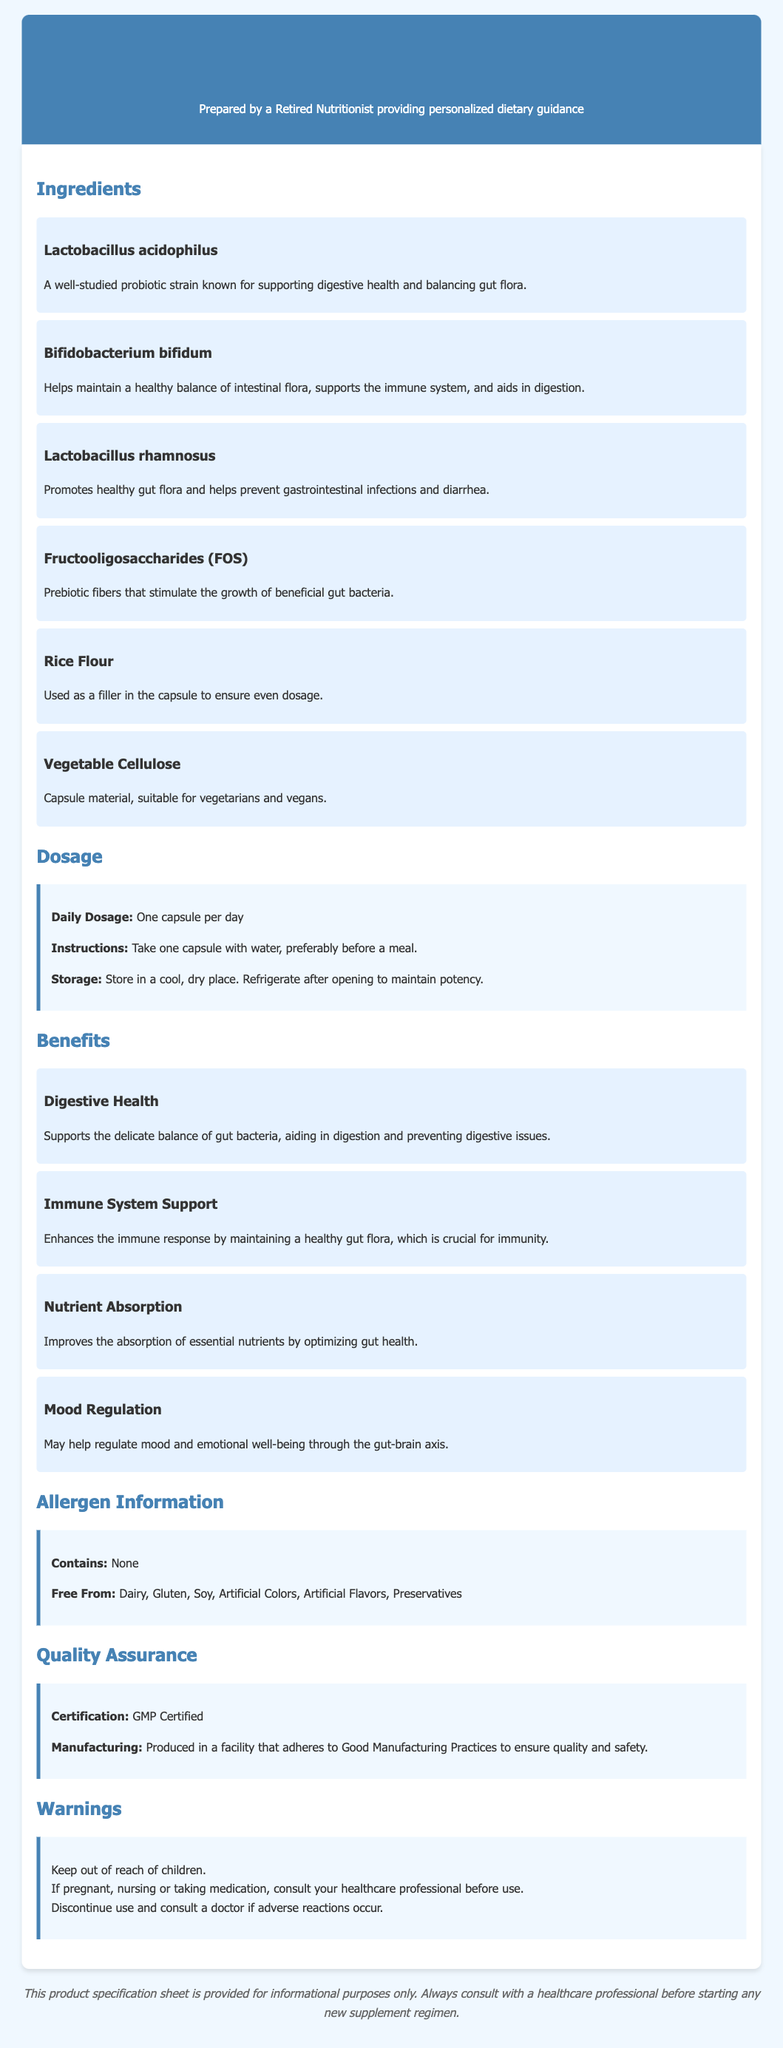What are the main ingredients? The main ingredients are listed under "Ingredients" in the document, and they include Lactobacillus acidophilus, Bifidobacterium bifidum, Lactobacillus rhamnosus, Fructooligosaccharides (FOS), Rice Flour, and Vegetable Cellulose.
Answer: Lactobacillus acidophilus, Bifidobacterium bifidum, Lactobacillus rhamnosus, Fructooligosaccharides (FOS), Rice Flour, Vegetable Cellulose What is the daily dosage? The daily dosage is specified in the "Dosage" section of the document and states to take one capsule per day.
Answer: One capsule per day What does FOS do? The function of Fructooligosaccharides (FOS) is described in the ingredient section, highlighting that it stimulates the growth of beneficial gut bacteria.
Answer: Stimulates growth of beneficial gut bacteria What benefit is linked to mood? The benefits associated with mood regulation are covered under the "Benefits" section, indicating its relationship to the gut-brain axis.
Answer: Mood Regulation What allergens are free from? The allergen information describes what the supplement is free from, which includes Dairy, Gluten, Soy, Artificial Colors, Artificial Flavors, and Preservatives.
Answer: Dairy, Gluten, Soy, Artificial Colors, Artificial Flavors, Preservatives How should the supplement be stored? The storage instructions are provided in the "Dosage" section, mentioning that it should be stored in a cool, dry place and refrigerated after opening.
Answer: Cool, dry place; refrigerate after opening What certification does the product have? The quality assurance section mentions the certification status, highlighting that it is GMP Certified.
Answer: GMP Certified Who should consult a doctor before use? The warnings section specifies that pregnant or nursing women, and those taking medication should consult a doctor before use.
Answer: Pregnant, nursing, or taking medication 